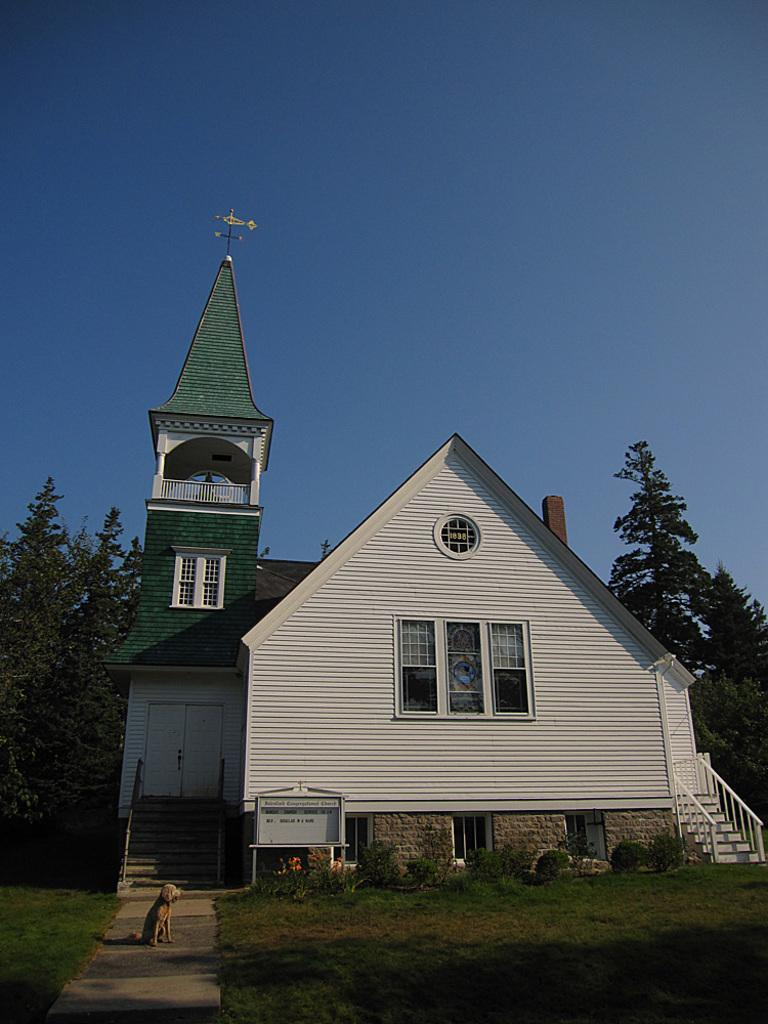What animal can be seen on the ground in the image? There is a dog on the ground in the image. What type of vegetation is present in the image? There is grass and plants in the image. Can you describe the house in the image? The house has windows, doors, and stairs in the image. What is visible in the background of the image? There are trees and the sky in the background of the image. What type of food is the monkey eating in the image? There is no monkey present in the image, and therefore no such activity can be observed. Can you describe the stranger standing next to the dog in the image? There is no stranger present in the image; only the dog, grass, plants, house, trees, and sky are visible. 